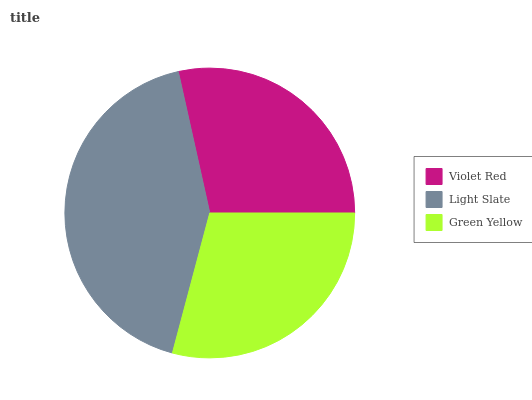Is Violet Red the minimum?
Answer yes or no. Yes. Is Light Slate the maximum?
Answer yes or no. Yes. Is Green Yellow the minimum?
Answer yes or no. No. Is Green Yellow the maximum?
Answer yes or no. No. Is Light Slate greater than Green Yellow?
Answer yes or no. Yes. Is Green Yellow less than Light Slate?
Answer yes or no. Yes. Is Green Yellow greater than Light Slate?
Answer yes or no. No. Is Light Slate less than Green Yellow?
Answer yes or no. No. Is Green Yellow the high median?
Answer yes or no. Yes. Is Green Yellow the low median?
Answer yes or no. Yes. Is Violet Red the high median?
Answer yes or no. No. Is Light Slate the low median?
Answer yes or no. No. 